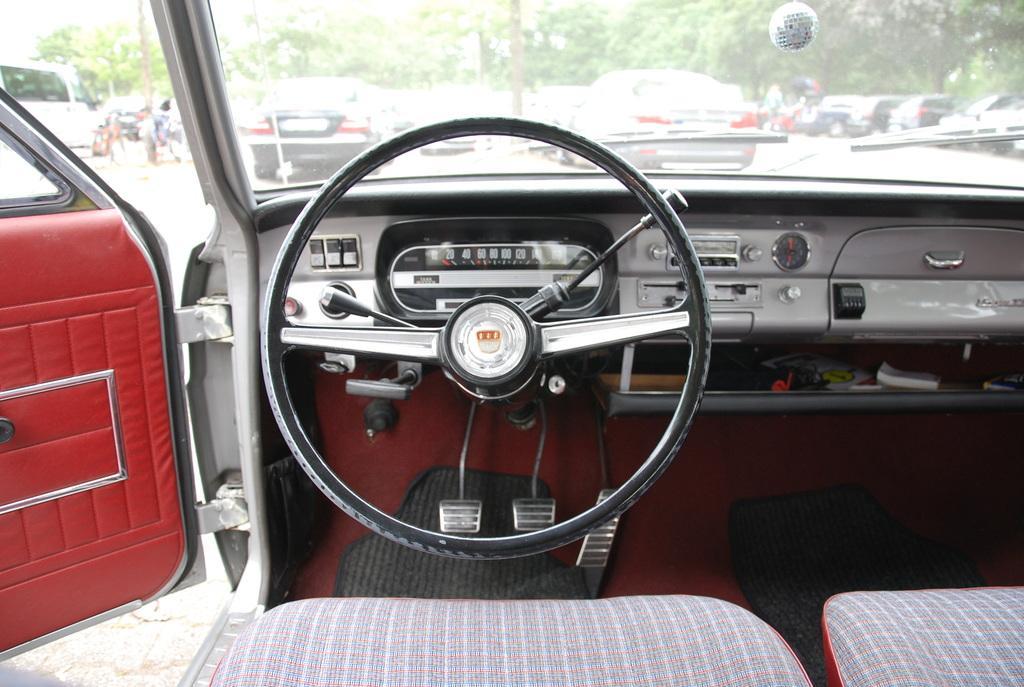How would you summarize this image in a sentence or two? This is the inner view of a car. There are 2 seats. There is a steering, clutch and brake at the bottom. The left door is open and there are poles, vehicles and trees at the back. 